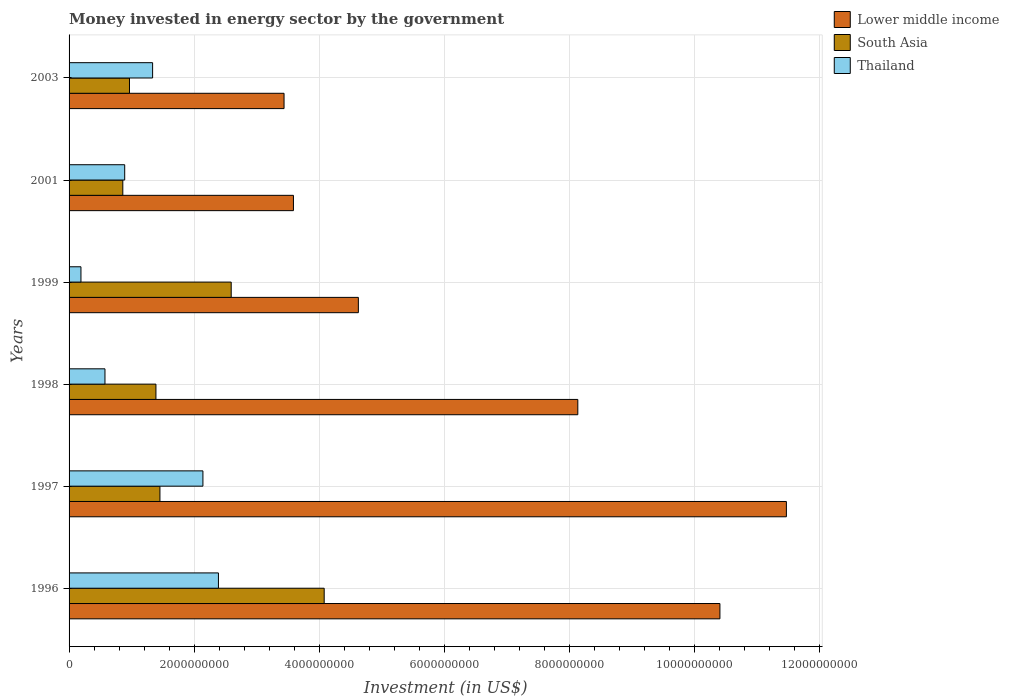Are the number of bars on each tick of the Y-axis equal?
Provide a succinct answer. Yes. How many bars are there on the 2nd tick from the bottom?
Offer a terse response. 3. In how many cases, is the number of bars for a given year not equal to the number of legend labels?
Your answer should be compact. 0. What is the money spent in energy sector in Thailand in 1997?
Your answer should be compact. 2.14e+09. Across all years, what is the maximum money spent in energy sector in South Asia?
Keep it short and to the point. 4.08e+09. Across all years, what is the minimum money spent in energy sector in Lower middle income?
Offer a very short reply. 3.44e+09. In which year was the money spent in energy sector in South Asia maximum?
Your response must be concise. 1996. What is the total money spent in energy sector in Lower middle income in the graph?
Your answer should be very brief. 4.17e+1. What is the difference between the money spent in energy sector in Lower middle income in 1998 and that in 1999?
Keep it short and to the point. 3.51e+09. What is the difference between the money spent in energy sector in South Asia in 2001 and the money spent in energy sector in Lower middle income in 1999?
Give a very brief answer. -3.77e+09. What is the average money spent in energy sector in Lower middle income per year?
Your answer should be very brief. 6.94e+09. In the year 1996, what is the difference between the money spent in energy sector in South Asia and money spent in energy sector in Thailand?
Make the answer very short. 1.69e+09. What is the ratio of the money spent in energy sector in South Asia in 1998 to that in 2003?
Your response must be concise. 1.44. Is the difference between the money spent in energy sector in South Asia in 1998 and 1999 greater than the difference between the money spent in energy sector in Thailand in 1998 and 1999?
Your response must be concise. No. What is the difference between the highest and the second highest money spent in energy sector in South Asia?
Your answer should be compact. 1.49e+09. What is the difference between the highest and the lowest money spent in energy sector in Lower middle income?
Offer a terse response. 8.03e+09. In how many years, is the money spent in energy sector in Lower middle income greater than the average money spent in energy sector in Lower middle income taken over all years?
Make the answer very short. 3. What does the 1st bar from the top in 1997 represents?
Make the answer very short. Thailand. Is it the case that in every year, the sum of the money spent in energy sector in Lower middle income and money spent in energy sector in South Asia is greater than the money spent in energy sector in Thailand?
Your response must be concise. Yes. How many bars are there?
Your response must be concise. 18. Are the values on the major ticks of X-axis written in scientific E-notation?
Your answer should be compact. No. Does the graph contain grids?
Your answer should be compact. Yes. Where does the legend appear in the graph?
Provide a short and direct response. Top right. How many legend labels are there?
Your answer should be compact. 3. How are the legend labels stacked?
Give a very brief answer. Vertical. What is the title of the graph?
Offer a terse response. Money invested in energy sector by the government. Does "Ethiopia" appear as one of the legend labels in the graph?
Your answer should be compact. No. What is the label or title of the X-axis?
Your response must be concise. Investment (in US$). What is the label or title of the Y-axis?
Offer a terse response. Years. What is the Investment (in US$) in Lower middle income in 1996?
Provide a short and direct response. 1.04e+1. What is the Investment (in US$) in South Asia in 1996?
Give a very brief answer. 4.08e+09. What is the Investment (in US$) in Thailand in 1996?
Give a very brief answer. 2.39e+09. What is the Investment (in US$) of Lower middle income in 1997?
Provide a short and direct response. 1.15e+1. What is the Investment (in US$) of South Asia in 1997?
Make the answer very short. 1.45e+09. What is the Investment (in US$) in Thailand in 1997?
Make the answer very short. 2.14e+09. What is the Investment (in US$) in Lower middle income in 1998?
Provide a succinct answer. 8.14e+09. What is the Investment (in US$) of South Asia in 1998?
Offer a terse response. 1.39e+09. What is the Investment (in US$) in Thailand in 1998?
Offer a very short reply. 5.74e+08. What is the Investment (in US$) in Lower middle income in 1999?
Provide a succinct answer. 4.63e+09. What is the Investment (in US$) in South Asia in 1999?
Give a very brief answer. 2.59e+09. What is the Investment (in US$) in Thailand in 1999?
Keep it short and to the point. 1.90e+08. What is the Investment (in US$) of Lower middle income in 2001?
Your answer should be compact. 3.59e+09. What is the Investment (in US$) in South Asia in 2001?
Offer a terse response. 8.60e+08. What is the Investment (in US$) in Thailand in 2001?
Your answer should be compact. 8.90e+08. What is the Investment (in US$) in Lower middle income in 2003?
Ensure brevity in your answer.  3.44e+09. What is the Investment (in US$) of South Asia in 2003?
Offer a very short reply. 9.66e+08. What is the Investment (in US$) in Thailand in 2003?
Ensure brevity in your answer.  1.34e+09. Across all years, what is the maximum Investment (in US$) of Lower middle income?
Your response must be concise. 1.15e+1. Across all years, what is the maximum Investment (in US$) in South Asia?
Offer a terse response. 4.08e+09. Across all years, what is the maximum Investment (in US$) of Thailand?
Ensure brevity in your answer.  2.39e+09. Across all years, what is the minimum Investment (in US$) in Lower middle income?
Offer a very short reply. 3.44e+09. Across all years, what is the minimum Investment (in US$) in South Asia?
Give a very brief answer. 8.60e+08. Across all years, what is the minimum Investment (in US$) of Thailand?
Make the answer very short. 1.90e+08. What is the total Investment (in US$) in Lower middle income in the graph?
Your answer should be compact. 4.17e+1. What is the total Investment (in US$) in South Asia in the graph?
Make the answer very short. 1.13e+1. What is the total Investment (in US$) of Thailand in the graph?
Your answer should be very brief. 7.52e+09. What is the difference between the Investment (in US$) of Lower middle income in 1996 and that in 1997?
Your response must be concise. -1.06e+09. What is the difference between the Investment (in US$) in South Asia in 1996 and that in 1997?
Provide a short and direct response. 2.63e+09. What is the difference between the Investment (in US$) in Thailand in 1996 and that in 1997?
Ensure brevity in your answer.  2.48e+08. What is the difference between the Investment (in US$) in Lower middle income in 1996 and that in 1998?
Your answer should be very brief. 2.27e+09. What is the difference between the Investment (in US$) of South Asia in 1996 and that in 1998?
Ensure brevity in your answer.  2.69e+09. What is the difference between the Investment (in US$) in Thailand in 1996 and that in 1998?
Ensure brevity in your answer.  1.81e+09. What is the difference between the Investment (in US$) in Lower middle income in 1996 and that in 1999?
Offer a very short reply. 5.78e+09. What is the difference between the Investment (in US$) in South Asia in 1996 and that in 1999?
Offer a terse response. 1.49e+09. What is the difference between the Investment (in US$) of Thailand in 1996 and that in 1999?
Your answer should be very brief. 2.20e+09. What is the difference between the Investment (in US$) in Lower middle income in 1996 and that in 2001?
Make the answer very short. 6.82e+09. What is the difference between the Investment (in US$) in South Asia in 1996 and that in 2001?
Keep it short and to the point. 3.22e+09. What is the difference between the Investment (in US$) in Thailand in 1996 and that in 2001?
Provide a succinct answer. 1.50e+09. What is the difference between the Investment (in US$) of Lower middle income in 1996 and that in 2003?
Give a very brief answer. 6.97e+09. What is the difference between the Investment (in US$) in South Asia in 1996 and that in 2003?
Make the answer very short. 3.11e+09. What is the difference between the Investment (in US$) in Thailand in 1996 and that in 2003?
Your answer should be compact. 1.05e+09. What is the difference between the Investment (in US$) in Lower middle income in 1997 and that in 1998?
Keep it short and to the point. 3.34e+09. What is the difference between the Investment (in US$) in South Asia in 1997 and that in 1998?
Provide a succinct answer. 6.39e+07. What is the difference between the Investment (in US$) in Thailand in 1997 and that in 1998?
Ensure brevity in your answer.  1.57e+09. What is the difference between the Investment (in US$) in Lower middle income in 1997 and that in 1999?
Your answer should be very brief. 6.85e+09. What is the difference between the Investment (in US$) of South Asia in 1997 and that in 1999?
Your answer should be very brief. -1.14e+09. What is the difference between the Investment (in US$) in Thailand in 1997 and that in 1999?
Offer a very short reply. 1.95e+09. What is the difference between the Investment (in US$) in Lower middle income in 1997 and that in 2001?
Give a very brief answer. 7.88e+09. What is the difference between the Investment (in US$) of South Asia in 1997 and that in 2001?
Your response must be concise. 5.94e+08. What is the difference between the Investment (in US$) of Thailand in 1997 and that in 2001?
Your response must be concise. 1.25e+09. What is the difference between the Investment (in US$) in Lower middle income in 1997 and that in 2003?
Your answer should be very brief. 8.03e+09. What is the difference between the Investment (in US$) in South Asia in 1997 and that in 2003?
Keep it short and to the point. 4.87e+08. What is the difference between the Investment (in US$) in Thailand in 1997 and that in 2003?
Your answer should be compact. 8.05e+08. What is the difference between the Investment (in US$) of Lower middle income in 1998 and that in 1999?
Offer a very short reply. 3.51e+09. What is the difference between the Investment (in US$) in South Asia in 1998 and that in 1999?
Provide a short and direct response. -1.20e+09. What is the difference between the Investment (in US$) in Thailand in 1998 and that in 1999?
Make the answer very short. 3.84e+08. What is the difference between the Investment (in US$) of Lower middle income in 1998 and that in 2001?
Give a very brief answer. 4.55e+09. What is the difference between the Investment (in US$) in South Asia in 1998 and that in 2001?
Provide a succinct answer. 5.30e+08. What is the difference between the Investment (in US$) in Thailand in 1998 and that in 2001?
Make the answer very short. -3.16e+08. What is the difference between the Investment (in US$) in Lower middle income in 1998 and that in 2003?
Offer a very short reply. 4.70e+09. What is the difference between the Investment (in US$) of South Asia in 1998 and that in 2003?
Make the answer very short. 4.23e+08. What is the difference between the Investment (in US$) of Thailand in 1998 and that in 2003?
Your answer should be very brief. -7.62e+08. What is the difference between the Investment (in US$) of Lower middle income in 1999 and that in 2001?
Offer a terse response. 1.04e+09. What is the difference between the Investment (in US$) of South Asia in 1999 and that in 2001?
Your answer should be very brief. 1.73e+09. What is the difference between the Investment (in US$) of Thailand in 1999 and that in 2001?
Offer a terse response. -7.00e+08. What is the difference between the Investment (in US$) of Lower middle income in 1999 and that in 2003?
Your response must be concise. 1.19e+09. What is the difference between the Investment (in US$) of South Asia in 1999 and that in 2003?
Offer a terse response. 1.63e+09. What is the difference between the Investment (in US$) of Thailand in 1999 and that in 2003?
Ensure brevity in your answer.  -1.15e+09. What is the difference between the Investment (in US$) in Lower middle income in 2001 and that in 2003?
Offer a very short reply. 1.50e+08. What is the difference between the Investment (in US$) in South Asia in 2001 and that in 2003?
Provide a short and direct response. -1.07e+08. What is the difference between the Investment (in US$) of Thailand in 2001 and that in 2003?
Your answer should be compact. -4.46e+08. What is the difference between the Investment (in US$) in Lower middle income in 1996 and the Investment (in US$) in South Asia in 1997?
Keep it short and to the point. 8.96e+09. What is the difference between the Investment (in US$) in Lower middle income in 1996 and the Investment (in US$) in Thailand in 1997?
Provide a succinct answer. 8.27e+09. What is the difference between the Investment (in US$) of South Asia in 1996 and the Investment (in US$) of Thailand in 1997?
Your answer should be very brief. 1.94e+09. What is the difference between the Investment (in US$) in Lower middle income in 1996 and the Investment (in US$) in South Asia in 1998?
Your response must be concise. 9.02e+09. What is the difference between the Investment (in US$) in Lower middle income in 1996 and the Investment (in US$) in Thailand in 1998?
Your answer should be very brief. 9.83e+09. What is the difference between the Investment (in US$) in South Asia in 1996 and the Investment (in US$) in Thailand in 1998?
Provide a short and direct response. 3.51e+09. What is the difference between the Investment (in US$) of Lower middle income in 1996 and the Investment (in US$) of South Asia in 1999?
Give a very brief answer. 7.82e+09. What is the difference between the Investment (in US$) in Lower middle income in 1996 and the Investment (in US$) in Thailand in 1999?
Provide a short and direct response. 1.02e+1. What is the difference between the Investment (in US$) of South Asia in 1996 and the Investment (in US$) of Thailand in 1999?
Provide a succinct answer. 3.89e+09. What is the difference between the Investment (in US$) of Lower middle income in 1996 and the Investment (in US$) of South Asia in 2001?
Your response must be concise. 9.55e+09. What is the difference between the Investment (in US$) of Lower middle income in 1996 and the Investment (in US$) of Thailand in 2001?
Your answer should be compact. 9.52e+09. What is the difference between the Investment (in US$) of South Asia in 1996 and the Investment (in US$) of Thailand in 2001?
Provide a short and direct response. 3.19e+09. What is the difference between the Investment (in US$) in Lower middle income in 1996 and the Investment (in US$) in South Asia in 2003?
Offer a very short reply. 9.44e+09. What is the difference between the Investment (in US$) in Lower middle income in 1996 and the Investment (in US$) in Thailand in 2003?
Keep it short and to the point. 9.07e+09. What is the difference between the Investment (in US$) in South Asia in 1996 and the Investment (in US$) in Thailand in 2003?
Make the answer very short. 2.74e+09. What is the difference between the Investment (in US$) of Lower middle income in 1997 and the Investment (in US$) of South Asia in 1998?
Provide a short and direct response. 1.01e+1. What is the difference between the Investment (in US$) of Lower middle income in 1997 and the Investment (in US$) of Thailand in 1998?
Give a very brief answer. 1.09e+1. What is the difference between the Investment (in US$) in South Asia in 1997 and the Investment (in US$) in Thailand in 1998?
Make the answer very short. 8.79e+08. What is the difference between the Investment (in US$) in Lower middle income in 1997 and the Investment (in US$) in South Asia in 1999?
Your answer should be compact. 8.88e+09. What is the difference between the Investment (in US$) in Lower middle income in 1997 and the Investment (in US$) in Thailand in 1999?
Your answer should be compact. 1.13e+1. What is the difference between the Investment (in US$) in South Asia in 1997 and the Investment (in US$) in Thailand in 1999?
Keep it short and to the point. 1.26e+09. What is the difference between the Investment (in US$) in Lower middle income in 1997 and the Investment (in US$) in South Asia in 2001?
Give a very brief answer. 1.06e+1. What is the difference between the Investment (in US$) in Lower middle income in 1997 and the Investment (in US$) in Thailand in 2001?
Give a very brief answer. 1.06e+1. What is the difference between the Investment (in US$) in South Asia in 1997 and the Investment (in US$) in Thailand in 2001?
Make the answer very short. 5.63e+08. What is the difference between the Investment (in US$) of Lower middle income in 1997 and the Investment (in US$) of South Asia in 2003?
Your answer should be compact. 1.05e+1. What is the difference between the Investment (in US$) of Lower middle income in 1997 and the Investment (in US$) of Thailand in 2003?
Offer a very short reply. 1.01e+1. What is the difference between the Investment (in US$) of South Asia in 1997 and the Investment (in US$) of Thailand in 2003?
Provide a short and direct response. 1.17e+08. What is the difference between the Investment (in US$) in Lower middle income in 1998 and the Investment (in US$) in South Asia in 1999?
Provide a short and direct response. 5.54e+09. What is the difference between the Investment (in US$) of Lower middle income in 1998 and the Investment (in US$) of Thailand in 1999?
Keep it short and to the point. 7.95e+09. What is the difference between the Investment (in US$) of South Asia in 1998 and the Investment (in US$) of Thailand in 1999?
Offer a very short reply. 1.20e+09. What is the difference between the Investment (in US$) of Lower middle income in 1998 and the Investment (in US$) of South Asia in 2001?
Give a very brief answer. 7.28e+09. What is the difference between the Investment (in US$) of Lower middle income in 1998 and the Investment (in US$) of Thailand in 2001?
Offer a very short reply. 7.25e+09. What is the difference between the Investment (in US$) of South Asia in 1998 and the Investment (in US$) of Thailand in 2001?
Keep it short and to the point. 5.00e+08. What is the difference between the Investment (in US$) in Lower middle income in 1998 and the Investment (in US$) in South Asia in 2003?
Your answer should be very brief. 7.17e+09. What is the difference between the Investment (in US$) in Lower middle income in 1998 and the Investment (in US$) in Thailand in 2003?
Keep it short and to the point. 6.80e+09. What is the difference between the Investment (in US$) in South Asia in 1998 and the Investment (in US$) in Thailand in 2003?
Offer a terse response. 5.33e+07. What is the difference between the Investment (in US$) in Lower middle income in 1999 and the Investment (in US$) in South Asia in 2001?
Offer a terse response. 3.77e+09. What is the difference between the Investment (in US$) in Lower middle income in 1999 and the Investment (in US$) in Thailand in 2001?
Your answer should be compact. 3.74e+09. What is the difference between the Investment (in US$) in South Asia in 1999 and the Investment (in US$) in Thailand in 2001?
Your answer should be very brief. 1.70e+09. What is the difference between the Investment (in US$) in Lower middle income in 1999 and the Investment (in US$) in South Asia in 2003?
Your answer should be very brief. 3.66e+09. What is the difference between the Investment (in US$) of Lower middle income in 1999 and the Investment (in US$) of Thailand in 2003?
Your response must be concise. 3.29e+09. What is the difference between the Investment (in US$) of South Asia in 1999 and the Investment (in US$) of Thailand in 2003?
Provide a succinct answer. 1.26e+09. What is the difference between the Investment (in US$) of Lower middle income in 2001 and the Investment (in US$) of South Asia in 2003?
Provide a short and direct response. 2.62e+09. What is the difference between the Investment (in US$) in Lower middle income in 2001 and the Investment (in US$) in Thailand in 2003?
Make the answer very short. 2.25e+09. What is the difference between the Investment (in US$) of South Asia in 2001 and the Investment (in US$) of Thailand in 2003?
Offer a very short reply. -4.76e+08. What is the average Investment (in US$) in Lower middle income per year?
Your answer should be very brief. 6.94e+09. What is the average Investment (in US$) in South Asia per year?
Make the answer very short. 1.89e+09. What is the average Investment (in US$) in Thailand per year?
Your answer should be compact. 1.25e+09. In the year 1996, what is the difference between the Investment (in US$) in Lower middle income and Investment (in US$) in South Asia?
Your answer should be very brief. 6.33e+09. In the year 1996, what is the difference between the Investment (in US$) in Lower middle income and Investment (in US$) in Thailand?
Keep it short and to the point. 8.02e+09. In the year 1996, what is the difference between the Investment (in US$) of South Asia and Investment (in US$) of Thailand?
Make the answer very short. 1.69e+09. In the year 1997, what is the difference between the Investment (in US$) of Lower middle income and Investment (in US$) of South Asia?
Give a very brief answer. 1.00e+1. In the year 1997, what is the difference between the Investment (in US$) of Lower middle income and Investment (in US$) of Thailand?
Your answer should be very brief. 9.33e+09. In the year 1997, what is the difference between the Investment (in US$) of South Asia and Investment (in US$) of Thailand?
Ensure brevity in your answer.  -6.87e+08. In the year 1998, what is the difference between the Investment (in US$) of Lower middle income and Investment (in US$) of South Asia?
Make the answer very short. 6.75e+09. In the year 1998, what is the difference between the Investment (in US$) of Lower middle income and Investment (in US$) of Thailand?
Your answer should be very brief. 7.56e+09. In the year 1998, what is the difference between the Investment (in US$) of South Asia and Investment (in US$) of Thailand?
Make the answer very short. 8.15e+08. In the year 1999, what is the difference between the Investment (in US$) in Lower middle income and Investment (in US$) in South Asia?
Keep it short and to the point. 2.03e+09. In the year 1999, what is the difference between the Investment (in US$) in Lower middle income and Investment (in US$) in Thailand?
Provide a succinct answer. 4.44e+09. In the year 1999, what is the difference between the Investment (in US$) of South Asia and Investment (in US$) of Thailand?
Provide a succinct answer. 2.40e+09. In the year 2001, what is the difference between the Investment (in US$) in Lower middle income and Investment (in US$) in South Asia?
Offer a terse response. 2.73e+09. In the year 2001, what is the difference between the Investment (in US$) of Lower middle income and Investment (in US$) of Thailand?
Provide a short and direct response. 2.70e+09. In the year 2001, what is the difference between the Investment (in US$) in South Asia and Investment (in US$) in Thailand?
Keep it short and to the point. -3.03e+07. In the year 2003, what is the difference between the Investment (in US$) in Lower middle income and Investment (in US$) in South Asia?
Ensure brevity in your answer.  2.47e+09. In the year 2003, what is the difference between the Investment (in US$) in Lower middle income and Investment (in US$) in Thailand?
Ensure brevity in your answer.  2.10e+09. In the year 2003, what is the difference between the Investment (in US$) of South Asia and Investment (in US$) of Thailand?
Your answer should be compact. -3.70e+08. What is the ratio of the Investment (in US$) of Lower middle income in 1996 to that in 1997?
Offer a very short reply. 0.91. What is the ratio of the Investment (in US$) in South Asia in 1996 to that in 1997?
Make the answer very short. 2.81. What is the ratio of the Investment (in US$) in Thailand in 1996 to that in 1997?
Offer a terse response. 1.12. What is the ratio of the Investment (in US$) in Lower middle income in 1996 to that in 1998?
Your response must be concise. 1.28. What is the ratio of the Investment (in US$) of South Asia in 1996 to that in 1998?
Offer a very short reply. 2.94. What is the ratio of the Investment (in US$) in Thailand in 1996 to that in 1998?
Your answer should be compact. 4.16. What is the ratio of the Investment (in US$) in Lower middle income in 1996 to that in 1999?
Your response must be concise. 2.25. What is the ratio of the Investment (in US$) in South Asia in 1996 to that in 1999?
Offer a terse response. 1.57. What is the ratio of the Investment (in US$) in Thailand in 1996 to that in 1999?
Make the answer very short. 12.57. What is the ratio of the Investment (in US$) in Lower middle income in 1996 to that in 2001?
Offer a very short reply. 2.9. What is the ratio of the Investment (in US$) of South Asia in 1996 to that in 2001?
Offer a very short reply. 4.75. What is the ratio of the Investment (in US$) in Thailand in 1996 to that in 2001?
Give a very brief answer. 2.68. What is the ratio of the Investment (in US$) in Lower middle income in 1996 to that in 2003?
Your answer should be very brief. 3.03. What is the ratio of the Investment (in US$) in South Asia in 1996 to that in 2003?
Provide a short and direct response. 4.22. What is the ratio of the Investment (in US$) of Thailand in 1996 to that in 2003?
Give a very brief answer. 1.79. What is the ratio of the Investment (in US$) of Lower middle income in 1997 to that in 1998?
Your response must be concise. 1.41. What is the ratio of the Investment (in US$) in South Asia in 1997 to that in 1998?
Make the answer very short. 1.05. What is the ratio of the Investment (in US$) of Thailand in 1997 to that in 1998?
Provide a short and direct response. 3.73. What is the ratio of the Investment (in US$) of Lower middle income in 1997 to that in 1999?
Provide a succinct answer. 2.48. What is the ratio of the Investment (in US$) of South Asia in 1997 to that in 1999?
Make the answer very short. 0.56. What is the ratio of the Investment (in US$) of Thailand in 1997 to that in 1999?
Offer a very short reply. 11.27. What is the ratio of the Investment (in US$) of Lower middle income in 1997 to that in 2001?
Offer a terse response. 3.2. What is the ratio of the Investment (in US$) in South Asia in 1997 to that in 2001?
Your answer should be compact. 1.69. What is the ratio of the Investment (in US$) of Thailand in 1997 to that in 2001?
Offer a very short reply. 2.41. What is the ratio of the Investment (in US$) in Lower middle income in 1997 to that in 2003?
Keep it short and to the point. 3.34. What is the ratio of the Investment (in US$) in South Asia in 1997 to that in 2003?
Provide a short and direct response. 1.5. What is the ratio of the Investment (in US$) of Thailand in 1997 to that in 2003?
Offer a terse response. 1.6. What is the ratio of the Investment (in US$) in Lower middle income in 1998 to that in 1999?
Make the answer very short. 1.76. What is the ratio of the Investment (in US$) of South Asia in 1998 to that in 1999?
Keep it short and to the point. 0.54. What is the ratio of the Investment (in US$) of Thailand in 1998 to that in 1999?
Keep it short and to the point. 3.02. What is the ratio of the Investment (in US$) of Lower middle income in 1998 to that in 2001?
Make the answer very short. 2.27. What is the ratio of the Investment (in US$) of South Asia in 1998 to that in 2001?
Your answer should be very brief. 1.62. What is the ratio of the Investment (in US$) of Thailand in 1998 to that in 2001?
Make the answer very short. 0.65. What is the ratio of the Investment (in US$) of Lower middle income in 1998 to that in 2003?
Give a very brief answer. 2.37. What is the ratio of the Investment (in US$) in South Asia in 1998 to that in 2003?
Ensure brevity in your answer.  1.44. What is the ratio of the Investment (in US$) of Thailand in 1998 to that in 2003?
Your answer should be very brief. 0.43. What is the ratio of the Investment (in US$) of Lower middle income in 1999 to that in 2001?
Offer a terse response. 1.29. What is the ratio of the Investment (in US$) of South Asia in 1999 to that in 2001?
Keep it short and to the point. 3.02. What is the ratio of the Investment (in US$) in Thailand in 1999 to that in 2001?
Make the answer very short. 0.21. What is the ratio of the Investment (in US$) of Lower middle income in 1999 to that in 2003?
Your answer should be compact. 1.35. What is the ratio of the Investment (in US$) of South Asia in 1999 to that in 2003?
Provide a succinct answer. 2.68. What is the ratio of the Investment (in US$) of Thailand in 1999 to that in 2003?
Give a very brief answer. 0.14. What is the ratio of the Investment (in US$) in Lower middle income in 2001 to that in 2003?
Keep it short and to the point. 1.04. What is the ratio of the Investment (in US$) of South Asia in 2001 to that in 2003?
Provide a succinct answer. 0.89. What is the ratio of the Investment (in US$) of Thailand in 2001 to that in 2003?
Your answer should be very brief. 0.67. What is the difference between the highest and the second highest Investment (in US$) in Lower middle income?
Your response must be concise. 1.06e+09. What is the difference between the highest and the second highest Investment (in US$) of South Asia?
Offer a very short reply. 1.49e+09. What is the difference between the highest and the second highest Investment (in US$) of Thailand?
Provide a succinct answer. 2.48e+08. What is the difference between the highest and the lowest Investment (in US$) in Lower middle income?
Ensure brevity in your answer.  8.03e+09. What is the difference between the highest and the lowest Investment (in US$) in South Asia?
Give a very brief answer. 3.22e+09. What is the difference between the highest and the lowest Investment (in US$) of Thailand?
Provide a succinct answer. 2.20e+09. 